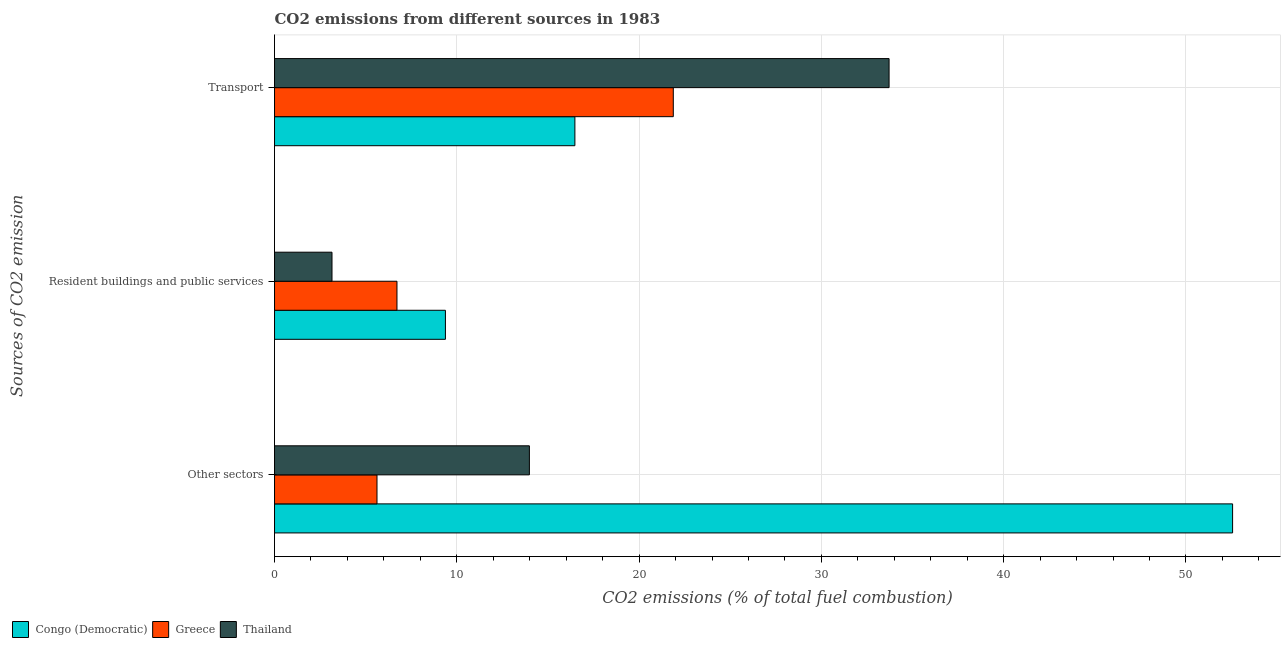How many different coloured bars are there?
Your answer should be very brief. 3. Are the number of bars per tick equal to the number of legend labels?
Your answer should be compact. Yes. How many bars are there on the 2nd tick from the top?
Provide a succinct answer. 3. What is the label of the 3rd group of bars from the top?
Ensure brevity in your answer.  Other sectors. What is the percentage of co2 emissions from resident buildings and public services in Thailand?
Offer a terse response. 3.15. Across all countries, what is the maximum percentage of co2 emissions from other sectors?
Give a very brief answer. 52.56. Across all countries, what is the minimum percentage of co2 emissions from other sectors?
Give a very brief answer. 5.62. In which country was the percentage of co2 emissions from resident buildings and public services maximum?
Your answer should be very brief. Congo (Democratic). In which country was the percentage of co2 emissions from other sectors minimum?
Offer a very short reply. Greece. What is the total percentage of co2 emissions from other sectors in the graph?
Provide a short and direct response. 72.16. What is the difference between the percentage of co2 emissions from transport in Congo (Democratic) and that in Thailand?
Your answer should be very brief. -17.24. What is the difference between the percentage of co2 emissions from other sectors in Congo (Democratic) and the percentage of co2 emissions from transport in Thailand?
Provide a succinct answer. 18.84. What is the average percentage of co2 emissions from other sectors per country?
Provide a short and direct response. 24.05. What is the difference between the percentage of co2 emissions from resident buildings and public services and percentage of co2 emissions from transport in Congo (Democratic)?
Offer a terse response. -7.1. What is the ratio of the percentage of co2 emissions from other sectors in Thailand to that in Congo (Democratic)?
Ensure brevity in your answer.  0.27. Is the difference between the percentage of co2 emissions from transport in Greece and Congo (Democratic) greater than the difference between the percentage of co2 emissions from resident buildings and public services in Greece and Congo (Democratic)?
Give a very brief answer. Yes. What is the difference between the highest and the second highest percentage of co2 emissions from transport?
Give a very brief answer. 11.84. What is the difference between the highest and the lowest percentage of co2 emissions from transport?
Ensure brevity in your answer.  17.24. What does the 3rd bar from the top in Resident buildings and public services represents?
Provide a succinct answer. Congo (Democratic). Are all the bars in the graph horizontal?
Offer a terse response. Yes. How many countries are there in the graph?
Ensure brevity in your answer.  3. Are the values on the major ticks of X-axis written in scientific E-notation?
Offer a very short reply. No. Does the graph contain any zero values?
Give a very brief answer. No. Does the graph contain grids?
Provide a succinct answer. Yes. How many legend labels are there?
Offer a terse response. 3. What is the title of the graph?
Make the answer very short. CO2 emissions from different sources in 1983. Does "Other small states" appear as one of the legend labels in the graph?
Offer a terse response. No. What is the label or title of the X-axis?
Your response must be concise. CO2 emissions (% of total fuel combustion). What is the label or title of the Y-axis?
Your response must be concise. Sources of CO2 emission. What is the CO2 emissions (% of total fuel combustion) in Congo (Democratic) in Other sectors?
Keep it short and to the point. 52.56. What is the CO2 emissions (% of total fuel combustion) in Greece in Other sectors?
Keep it short and to the point. 5.62. What is the CO2 emissions (% of total fuel combustion) in Thailand in Other sectors?
Provide a succinct answer. 13.98. What is the CO2 emissions (% of total fuel combustion) of Congo (Democratic) in Resident buildings and public services?
Offer a terse response. 9.38. What is the CO2 emissions (% of total fuel combustion) in Greece in Resident buildings and public services?
Your answer should be compact. 6.72. What is the CO2 emissions (% of total fuel combustion) of Thailand in Resident buildings and public services?
Provide a short and direct response. 3.15. What is the CO2 emissions (% of total fuel combustion) of Congo (Democratic) in Transport?
Keep it short and to the point. 16.48. What is the CO2 emissions (% of total fuel combustion) in Greece in Transport?
Give a very brief answer. 21.88. What is the CO2 emissions (% of total fuel combustion) of Thailand in Transport?
Provide a succinct answer. 33.71. Across all Sources of CO2 emission, what is the maximum CO2 emissions (% of total fuel combustion) in Congo (Democratic)?
Provide a succinct answer. 52.56. Across all Sources of CO2 emission, what is the maximum CO2 emissions (% of total fuel combustion) in Greece?
Offer a very short reply. 21.88. Across all Sources of CO2 emission, what is the maximum CO2 emissions (% of total fuel combustion) of Thailand?
Offer a terse response. 33.71. Across all Sources of CO2 emission, what is the minimum CO2 emissions (% of total fuel combustion) of Congo (Democratic)?
Your response must be concise. 9.38. Across all Sources of CO2 emission, what is the minimum CO2 emissions (% of total fuel combustion) of Greece?
Make the answer very short. 5.62. Across all Sources of CO2 emission, what is the minimum CO2 emissions (% of total fuel combustion) in Thailand?
Your answer should be very brief. 3.15. What is the total CO2 emissions (% of total fuel combustion) in Congo (Democratic) in the graph?
Ensure brevity in your answer.  78.41. What is the total CO2 emissions (% of total fuel combustion) in Greece in the graph?
Your response must be concise. 34.21. What is the total CO2 emissions (% of total fuel combustion) in Thailand in the graph?
Provide a short and direct response. 50.85. What is the difference between the CO2 emissions (% of total fuel combustion) in Congo (Democratic) in Other sectors and that in Resident buildings and public services?
Provide a short and direct response. 43.18. What is the difference between the CO2 emissions (% of total fuel combustion) in Greece in Other sectors and that in Resident buildings and public services?
Offer a terse response. -1.1. What is the difference between the CO2 emissions (% of total fuel combustion) of Thailand in Other sectors and that in Resident buildings and public services?
Offer a terse response. 10.83. What is the difference between the CO2 emissions (% of total fuel combustion) of Congo (Democratic) in Other sectors and that in Transport?
Provide a succinct answer. 36.08. What is the difference between the CO2 emissions (% of total fuel combustion) in Greece in Other sectors and that in Transport?
Offer a very short reply. -16.25. What is the difference between the CO2 emissions (% of total fuel combustion) in Thailand in Other sectors and that in Transport?
Your answer should be very brief. -19.73. What is the difference between the CO2 emissions (% of total fuel combustion) of Congo (Democratic) in Resident buildings and public services and that in Transport?
Offer a very short reply. -7.1. What is the difference between the CO2 emissions (% of total fuel combustion) in Greece in Resident buildings and public services and that in Transport?
Ensure brevity in your answer.  -15.16. What is the difference between the CO2 emissions (% of total fuel combustion) in Thailand in Resident buildings and public services and that in Transport?
Offer a terse response. -30.56. What is the difference between the CO2 emissions (% of total fuel combustion) of Congo (Democratic) in Other sectors and the CO2 emissions (% of total fuel combustion) of Greece in Resident buildings and public services?
Your response must be concise. 45.84. What is the difference between the CO2 emissions (% of total fuel combustion) of Congo (Democratic) in Other sectors and the CO2 emissions (% of total fuel combustion) of Thailand in Resident buildings and public services?
Offer a terse response. 49.4. What is the difference between the CO2 emissions (% of total fuel combustion) of Greece in Other sectors and the CO2 emissions (% of total fuel combustion) of Thailand in Resident buildings and public services?
Provide a succinct answer. 2.47. What is the difference between the CO2 emissions (% of total fuel combustion) of Congo (Democratic) in Other sectors and the CO2 emissions (% of total fuel combustion) of Greece in Transport?
Ensure brevity in your answer.  30.68. What is the difference between the CO2 emissions (% of total fuel combustion) of Congo (Democratic) in Other sectors and the CO2 emissions (% of total fuel combustion) of Thailand in Transport?
Offer a very short reply. 18.84. What is the difference between the CO2 emissions (% of total fuel combustion) of Greece in Other sectors and the CO2 emissions (% of total fuel combustion) of Thailand in Transport?
Give a very brief answer. -28.09. What is the difference between the CO2 emissions (% of total fuel combustion) of Congo (Democratic) in Resident buildings and public services and the CO2 emissions (% of total fuel combustion) of Thailand in Transport?
Ensure brevity in your answer.  -24.34. What is the difference between the CO2 emissions (% of total fuel combustion) of Greece in Resident buildings and public services and the CO2 emissions (% of total fuel combustion) of Thailand in Transport?
Provide a succinct answer. -27. What is the average CO2 emissions (% of total fuel combustion) of Congo (Democratic) per Sources of CO2 emission?
Provide a short and direct response. 26.14. What is the average CO2 emissions (% of total fuel combustion) in Greece per Sources of CO2 emission?
Provide a succinct answer. 11.4. What is the average CO2 emissions (% of total fuel combustion) in Thailand per Sources of CO2 emission?
Keep it short and to the point. 16.95. What is the difference between the CO2 emissions (% of total fuel combustion) of Congo (Democratic) and CO2 emissions (% of total fuel combustion) of Greece in Other sectors?
Your answer should be compact. 46.94. What is the difference between the CO2 emissions (% of total fuel combustion) of Congo (Democratic) and CO2 emissions (% of total fuel combustion) of Thailand in Other sectors?
Offer a terse response. 38.58. What is the difference between the CO2 emissions (% of total fuel combustion) of Greece and CO2 emissions (% of total fuel combustion) of Thailand in Other sectors?
Give a very brief answer. -8.36. What is the difference between the CO2 emissions (% of total fuel combustion) of Congo (Democratic) and CO2 emissions (% of total fuel combustion) of Greece in Resident buildings and public services?
Your answer should be very brief. 2.66. What is the difference between the CO2 emissions (% of total fuel combustion) of Congo (Democratic) and CO2 emissions (% of total fuel combustion) of Thailand in Resident buildings and public services?
Provide a short and direct response. 6.22. What is the difference between the CO2 emissions (% of total fuel combustion) of Greece and CO2 emissions (% of total fuel combustion) of Thailand in Resident buildings and public services?
Provide a short and direct response. 3.56. What is the difference between the CO2 emissions (% of total fuel combustion) in Congo (Democratic) and CO2 emissions (% of total fuel combustion) in Greece in Transport?
Keep it short and to the point. -5.4. What is the difference between the CO2 emissions (% of total fuel combustion) in Congo (Democratic) and CO2 emissions (% of total fuel combustion) in Thailand in Transport?
Give a very brief answer. -17.24. What is the difference between the CO2 emissions (% of total fuel combustion) in Greece and CO2 emissions (% of total fuel combustion) in Thailand in Transport?
Give a very brief answer. -11.84. What is the ratio of the CO2 emissions (% of total fuel combustion) of Congo (Democratic) in Other sectors to that in Resident buildings and public services?
Your answer should be very brief. 5.61. What is the ratio of the CO2 emissions (% of total fuel combustion) in Greece in Other sectors to that in Resident buildings and public services?
Your response must be concise. 0.84. What is the ratio of the CO2 emissions (% of total fuel combustion) of Thailand in Other sectors to that in Resident buildings and public services?
Offer a very short reply. 4.44. What is the ratio of the CO2 emissions (% of total fuel combustion) of Congo (Democratic) in Other sectors to that in Transport?
Provide a short and direct response. 3.19. What is the ratio of the CO2 emissions (% of total fuel combustion) of Greece in Other sectors to that in Transport?
Ensure brevity in your answer.  0.26. What is the ratio of the CO2 emissions (% of total fuel combustion) of Thailand in Other sectors to that in Transport?
Your answer should be compact. 0.41. What is the ratio of the CO2 emissions (% of total fuel combustion) in Congo (Democratic) in Resident buildings and public services to that in Transport?
Offer a very short reply. 0.57. What is the ratio of the CO2 emissions (% of total fuel combustion) in Greece in Resident buildings and public services to that in Transport?
Keep it short and to the point. 0.31. What is the ratio of the CO2 emissions (% of total fuel combustion) in Thailand in Resident buildings and public services to that in Transport?
Your answer should be compact. 0.09. What is the difference between the highest and the second highest CO2 emissions (% of total fuel combustion) in Congo (Democratic)?
Ensure brevity in your answer.  36.08. What is the difference between the highest and the second highest CO2 emissions (% of total fuel combustion) of Greece?
Provide a succinct answer. 15.16. What is the difference between the highest and the second highest CO2 emissions (% of total fuel combustion) in Thailand?
Offer a very short reply. 19.73. What is the difference between the highest and the lowest CO2 emissions (% of total fuel combustion) of Congo (Democratic)?
Provide a short and direct response. 43.18. What is the difference between the highest and the lowest CO2 emissions (% of total fuel combustion) in Greece?
Keep it short and to the point. 16.25. What is the difference between the highest and the lowest CO2 emissions (% of total fuel combustion) of Thailand?
Keep it short and to the point. 30.56. 